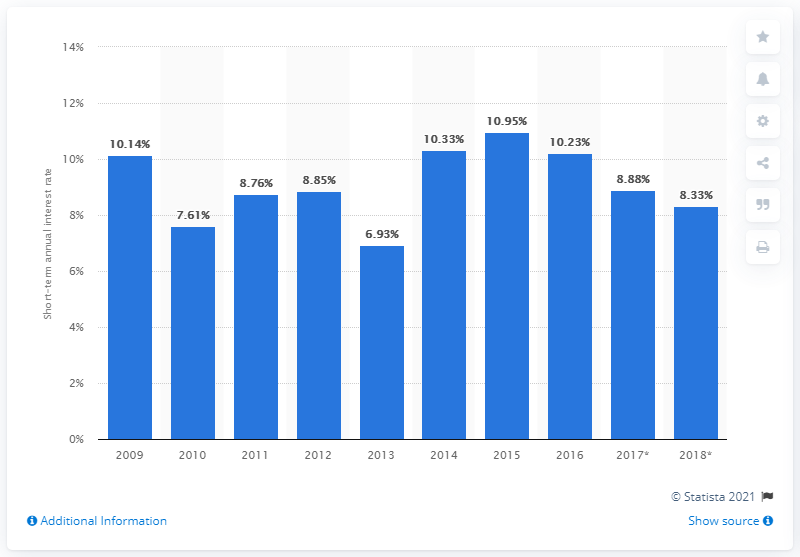Identify some key points in this picture. At its peak in 2015, Turkey's short-term interest rate was 10.95%. In 2013, Turkey's short-term interest rate reached its lowest at 6.93%. According to the projected data, the short-term interest rate in Turkey is expected to be 6.93% in 2017 and 2018. 